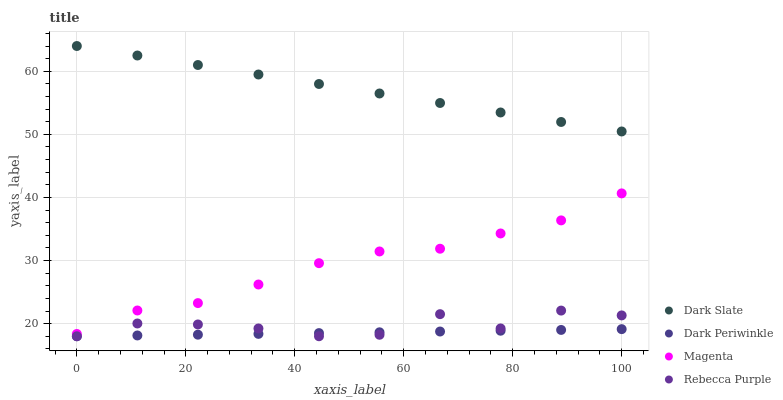Does Dark Periwinkle have the minimum area under the curve?
Answer yes or no. Yes. Does Dark Slate have the maximum area under the curve?
Answer yes or no. Yes. Does Magenta have the minimum area under the curve?
Answer yes or no. No. Does Magenta have the maximum area under the curve?
Answer yes or no. No. Is Dark Periwinkle the smoothest?
Answer yes or no. Yes. Is Rebecca Purple the roughest?
Answer yes or no. Yes. Is Magenta the smoothest?
Answer yes or no. No. Is Magenta the roughest?
Answer yes or no. No. Does Dark Periwinkle have the lowest value?
Answer yes or no. Yes. Does Magenta have the lowest value?
Answer yes or no. No. Does Dark Slate have the highest value?
Answer yes or no. Yes. Does Magenta have the highest value?
Answer yes or no. No. Is Rebecca Purple less than Magenta?
Answer yes or no. Yes. Is Magenta greater than Rebecca Purple?
Answer yes or no. Yes. Does Dark Periwinkle intersect Rebecca Purple?
Answer yes or no. Yes. Is Dark Periwinkle less than Rebecca Purple?
Answer yes or no. No. Is Dark Periwinkle greater than Rebecca Purple?
Answer yes or no. No. Does Rebecca Purple intersect Magenta?
Answer yes or no. No. 